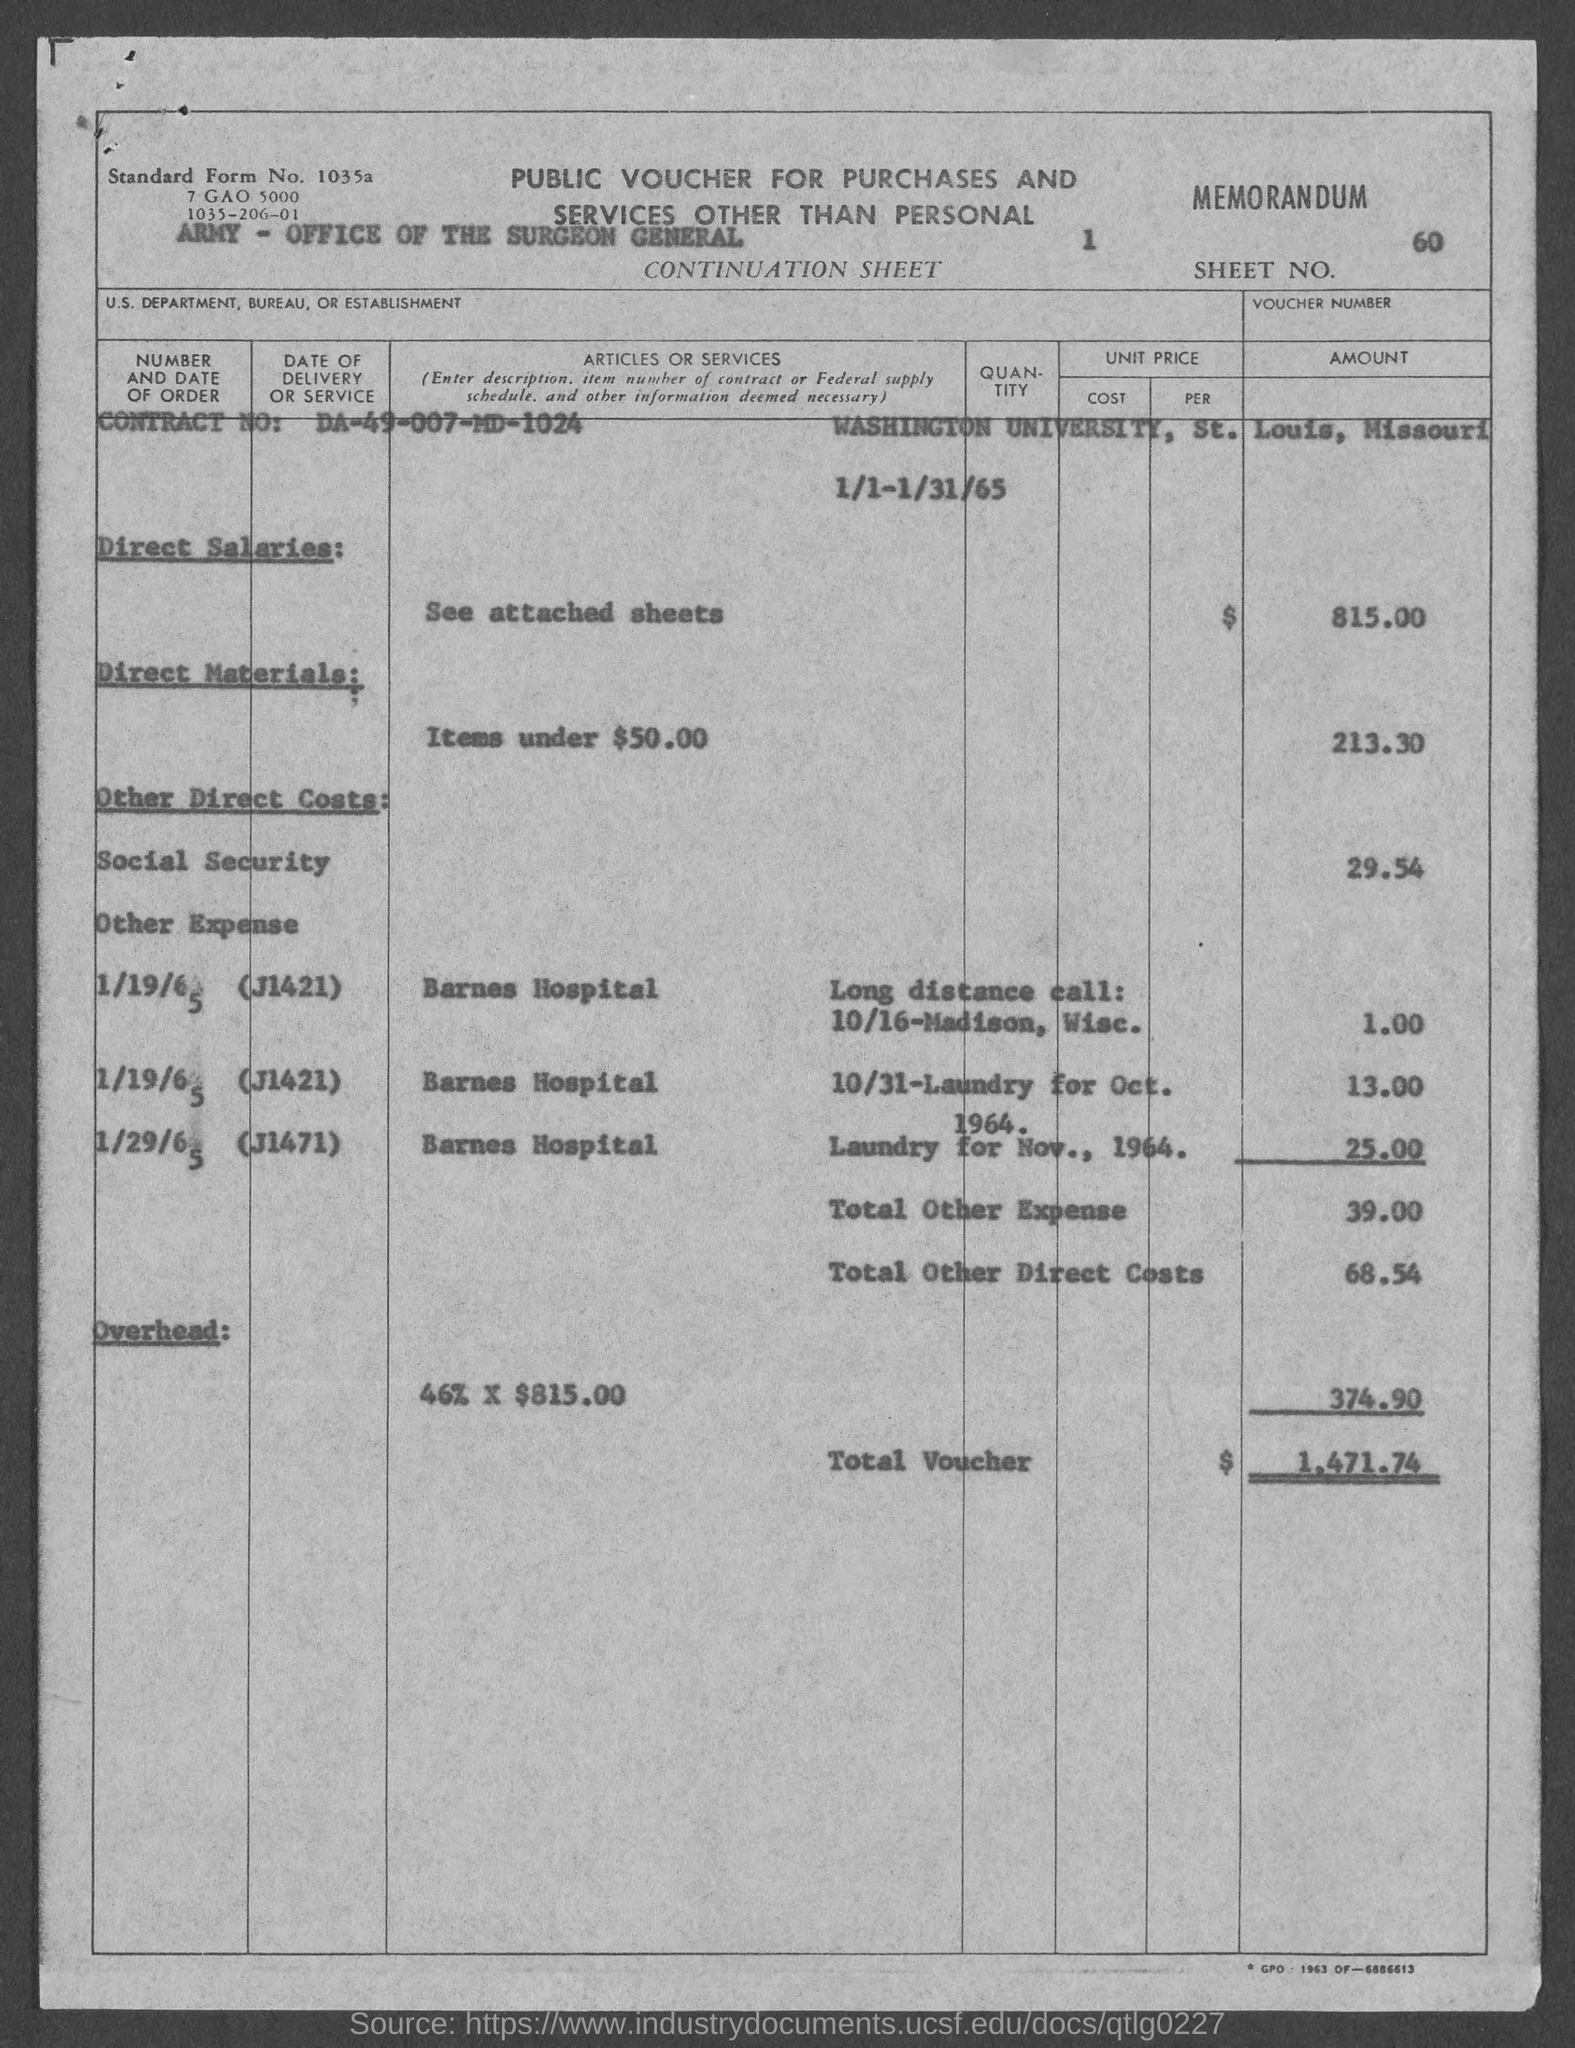Identify some key points in this picture. The contract number is DA-49-007-MD-1024. The total other expense amount is 39.00. The total voucher amount is $1,471.74. The total direct costs other than labor are $68.54. What is Sheet No. 60?" is a question that asks for information about a specific sheet. 